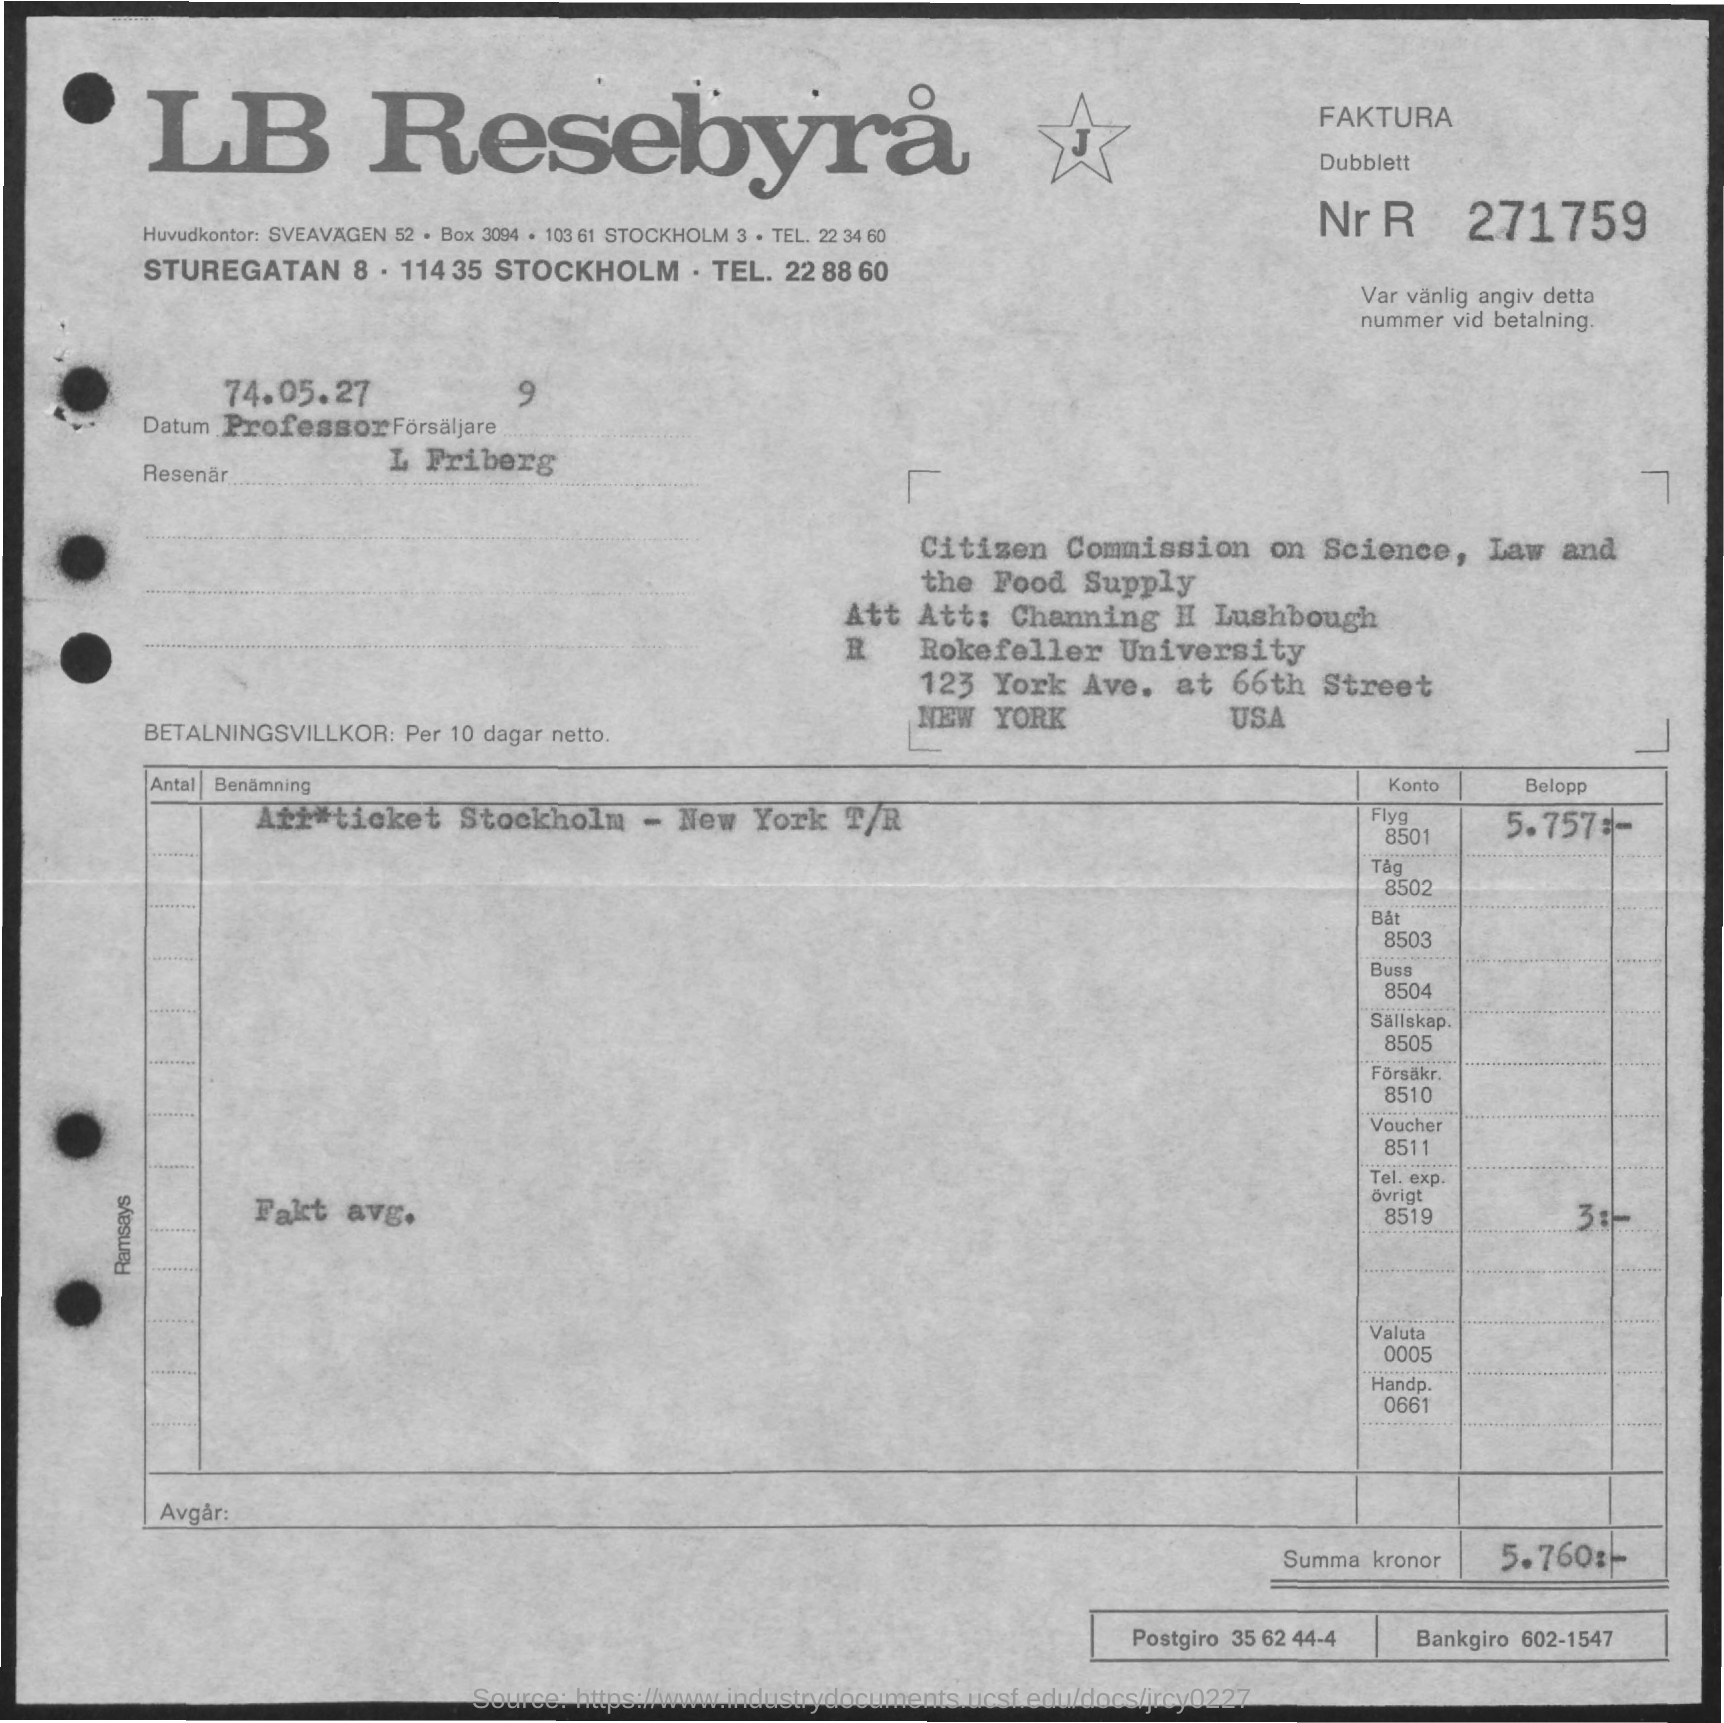Give some essential details in this illustration. The Bankgiro is a specific type of account number that consists of six digits, the first two of which are the account number, and the last four are the check number. The format is always 602-1547, where the first two digits are the account number and the last four are the check number. The Postgiro is a Danish postal service that offers various financial services, including the sending and receiving of money, as well as the exchange of foreign currency. The Summa kronor is approximately 5,760 Swedish kronor. The title of the document is "LB Resebyra." 